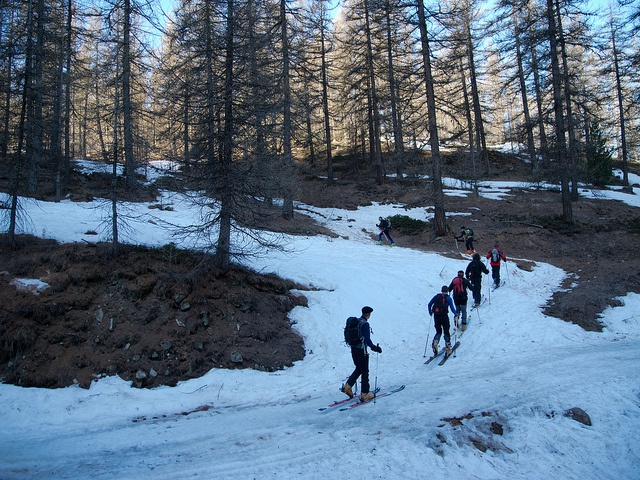Describe the objects in this image and their specific colors. I can see people in black, navy, lightblue, and blue tones, people in black, navy, and gray tones, people in black, navy, and purple tones, people in black, navy, and gray tones, and skis in black, gray, and darkgray tones in this image. 